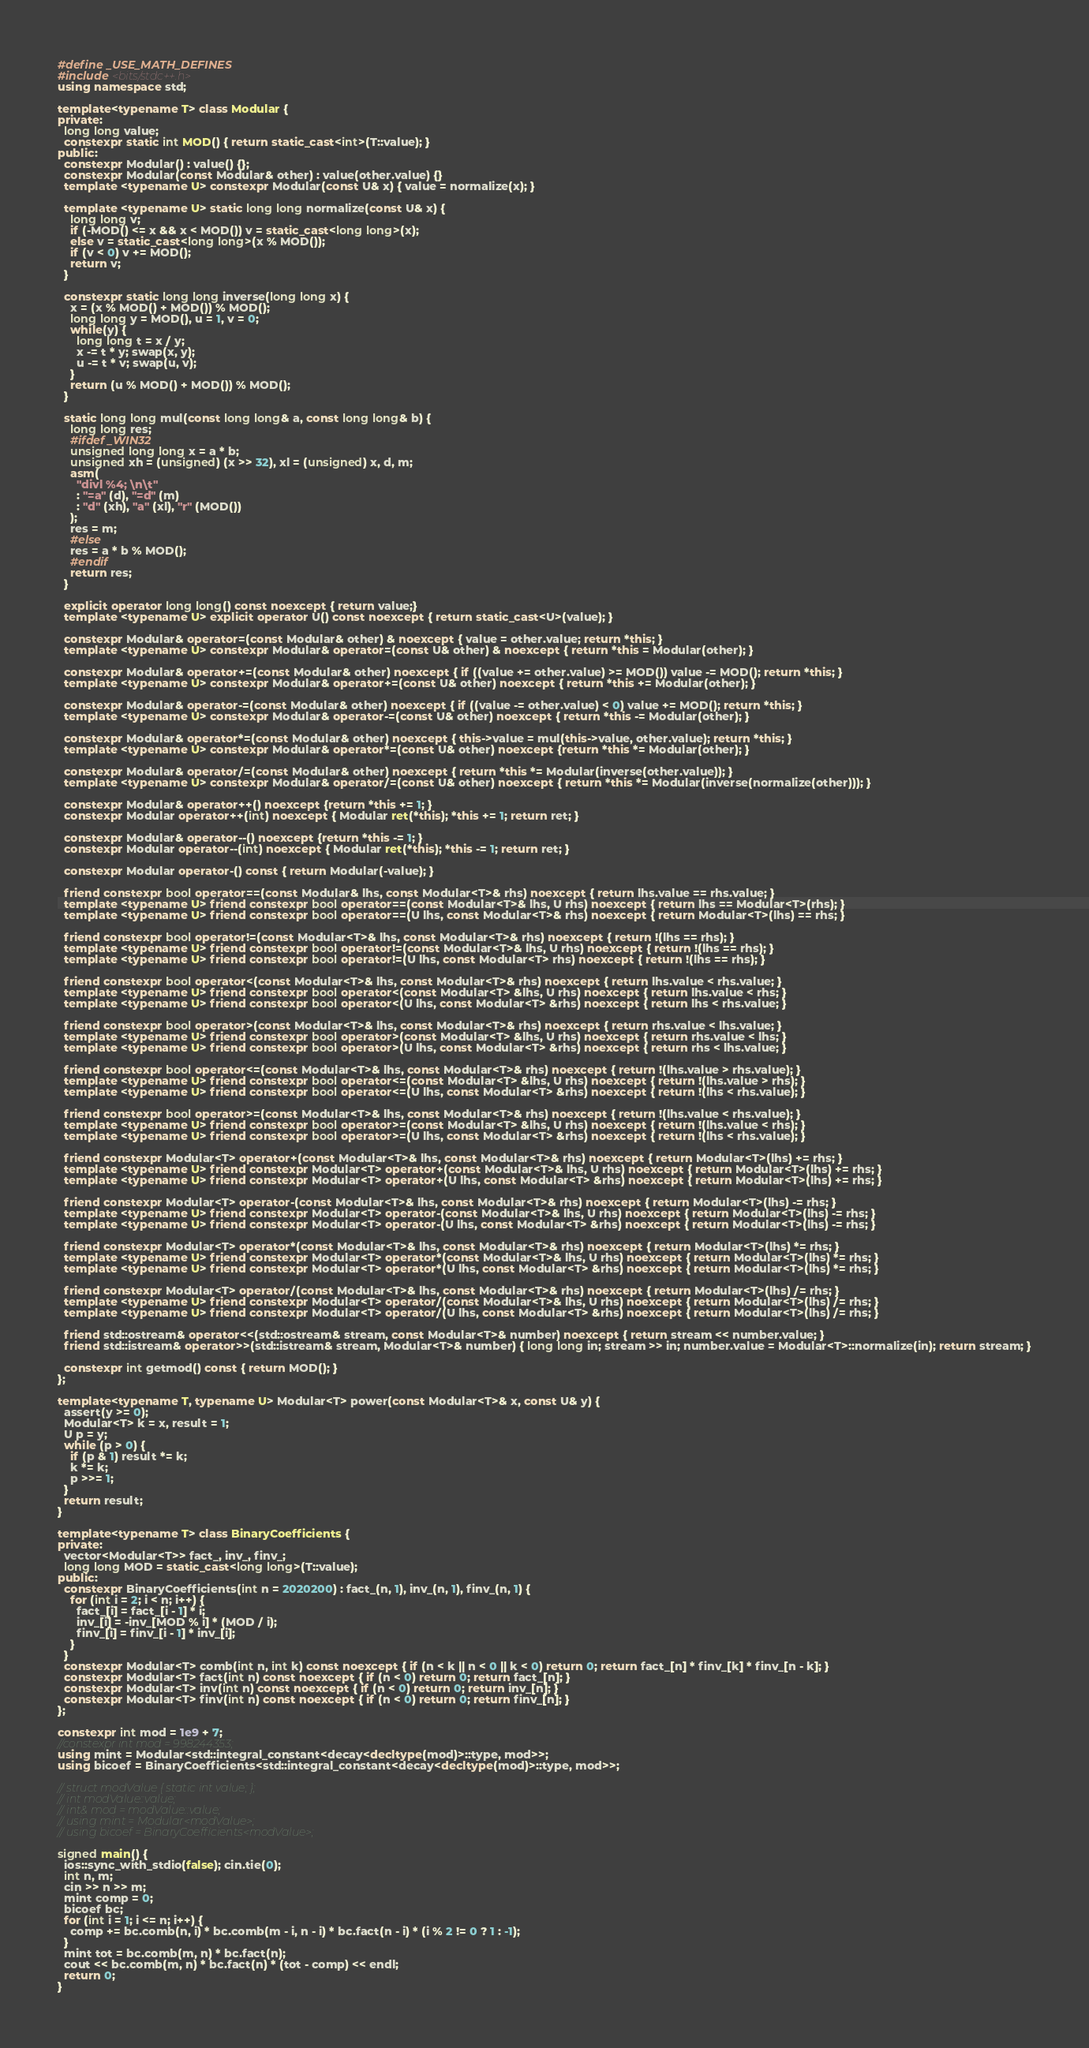<code> <loc_0><loc_0><loc_500><loc_500><_C++_>#define _USE_MATH_DEFINES
#include <bits/stdc++.h>
using namespace std;

template<typename T> class Modular {
private:
  long long value;
  constexpr static int MOD() { return static_cast<int>(T::value); }
public:
  constexpr Modular() : value() {};
  constexpr Modular(const Modular& other) : value(other.value) {}
  template <typename U> constexpr Modular(const U& x) { value = normalize(x); }

  template <typename U> static long long normalize(const U& x) {
    long long v;
    if (-MOD() <= x && x < MOD()) v = static_cast<long long>(x);
    else v = static_cast<long long>(x % MOD());
    if (v < 0) v += MOD();
    return v;
  }

  constexpr static long long inverse(long long x) {
    x = (x % MOD() + MOD()) % MOD();
    long long y = MOD(), u = 1, v = 0;
    while(y) {
      long long t = x / y;
      x -= t * y; swap(x, y);
      u -= t * v; swap(u, v);
    }
    return (u % MOD() + MOD()) % MOD();
  }
  
  static long long mul(const long long& a, const long long& b) {
    long long res;
    #ifdef _WIN32
    unsigned long long x = a * b;
    unsigned xh = (unsigned) (x >> 32), xl = (unsigned) x, d, m;
    asm(
      "divl %4; \n\t"
      : "=a" (d), "=d" (m)
      : "d" (xh), "a" (xl), "r" (MOD())
    );
    res = m;
    #else
    res = a * b % MOD();
    #endif
    return res;
  }

  explicit operator long long() const noexcept { return value;}
  template <typename U> explicit operator U() const noexcept { return static_cast<U>(value); }

  constexpr Modular& operator=(const Modular& other) & noexcept { value = other.value; return *this; }
  template <typename U> constexpr Modular& operator=(const U& other) & noexcept { return *this = Modular(other); }

  constexpr Modular& operator+=(const Modular& other) noexcept { if ((value += other.value) >= MOD()) value -= MOD(); return *this; }
  template <typename U> constexpr Modular& operator+=(const U& other) noexcept { return *this += Modular(other); }

  constexpr Modular& operator-=(const Modular& other) noexcept { if ((value -= other.value) < 0) value += MOD(); return *this; }
  template <typename U> constexpr Modular& operator-=(const U& other) noexcept { return *this -= Modular(other); }

  constexpr Modular& operator*=(const Modular& other) noexcept { this->value = mul(this->value, other.value); return *this; }
  template <typename U> constexpr Modular& operator*=(const U& other) noexcept {return *this *= Modular(other); }

  constexpr Modular& operator/=(const Modular& other) noexcept { return *this *= Modular(inverse(other.value)); }
  template <typename U> constexpr Modular& operator/=(const U& other) noexcept { return *this *= Modular(inverse(normalize(other))); }

  constexpr Modular& operator++() noexcept {return *this += 1; }
  constexpr Modular operator++(int) noexcept { Modular ret(*this); *this += 1; return ret; }

  constexpr Modular& operator--() noexcept {return *this -= 1; }
  constexpr Modular operator--(int) noexcept { Modular ret(*this); *this -= 1; return ret; }

  constexpr Modular operator-() const { return Modular(-value); }

  friend constexpr bool operator==(const Modular& lhs, const Modular<T>& rhs) noexcept { return lhs.value == rhs.value; }
  template <typename U> friend constexpr bool operator==(const Modular<T>& lhs, U rhs) noexcept { return lhs == Modular<T>(rhs); }
  template <typename U> friend constexpr bool operator==(U lhs, const Modular<T>& rhs) noexcept { return Modular<T>(lhs) == rhs; }

  friend constexpr bool operator!=(const Modular<T>& lhs, const Modular<T>& rhs) noexcept { return !(lhs == rhs); }
  template <typename U> friend constexpr bool operator!=(const Modular<T>& lhs, U rhs) noexcept { return !(lhs == rhs); }
  template <typename U> friend constexpr bool operator!=(U lhs, const Modular<T> rhs) noexcept { return !(lhs == rhs); }

  friend constexpr bool operator<(const Modular<T>& lhs, const Modular<T>& rhs) noexcept { return lhs.value < rhs.value; }
  template <typename U> friend constexpr bool operator<(const Modular<T> &lhs, U rhs) noexcept { return lhs.value < rhs; }
  template <typename U> friend constexpr bool operator<(U lhs, const Modular<T> &rhs) noexcept { return lhs < rhs.value; }

  friend constexpr bool operator>(const Modular<T>& lhs, const Modular<T>& rhs) noexcept { return rhs.value < lhs.value; }
  template <typename U> friend constexpr bool operator>(const Modular<T> &lhs, U rhs) noexcept { return rhs.value < lhs; }
  template <typename U> friend constexpr bool operator>(U lhs, const Modular<T> &rhs) noexcept { return rhs < lhs.value; }

  friend constexpr bool operator<=(const Modular<T>& lhs, const Modular<T>& rhs) noexcept { return !(lhs.value > rhs.value); }
  template <typename U> friend constexpr bool operator<=(const Modular<T> &lhs, U rhs) noexcept { return !(lhs.value > rhs); }
  template <typename U> friend constexpr bool operator<=(U lhs, const Modular<T> &rhs) noexcept { return !(lhs < rhs.value); }

  friend constexpr bool operator>=(const Modular<T>& lhs, const Modular<T>& rhs) noexcept { return !(lhs.value < rhs.value); }
  template <typename U> friend constexpr bool operator>=(const Modular<T> &lhs, U rhs) noexcept { return !(lhs.value < rhs); }
  template <typename U> friend constexpr bool operator>=(U lhs, const Modular<T> &rhs) noexcept { return !(lhs < rhs.value); }

  friend constexpr Modular<T> operator+(const Modular<T>& lhs, const Modular<T>& rhs) noexcept { return Modular<T>(lhs) += rhs; }
  template <typename U> friend constexpr Modular<T> operator+(const Modular<T>& lhs, U rhs) noexcept { return Modular<T>(lhs) += rhs; }
  template <typename U> friend constexpr Modular<T> operator+(U lhs, const Modular<T> &rhs) noexcept { return Modular<T>(lhs) += rhs; }

  friend constexpr Modular<T> operator-(const Modular<T>& lhs, const Modular<T>& rhs) noexcept { return Modular<T>(lhs) -= rhs; }
  template <typename U> friend constexpr Modular<T> operator-(const Modular<T>& lhs, U rhs) noexcept { return Modular<T>(lhs) -= rhs; }
  template <typename U> friend constexpr Modular<T> operator-(U lhs, const Modular<T> &rhs) noexcept { return Modular<T>(lhs) -= rhs; }

  friend constexpr Modular<T> operator*(const Modular<T>& lhs, const Modular<T>& rhs) noexcept { return Modular<T>(lhs) *= rhs; }
  template <typename U> friend constexpr Modular<T> operator*(const Modular<T>& lhs, U rhs) noexcept { return Modular<T>(lhs) *= rhs; }
  template <typename U> friend constexpr Modular<T> operator*(U lhs, const Modular<T> &rhs) noexcept { return Modular<T>(lhs) *= rhs; }

  friend constexpr Modular<T> operator/(const Modular<T>& lhs, const Modular<T>& rhs) noexcept { return Modular<T>(lhs) /= rhs; }
  template <typename U> friend constexpr Modular<T> operator/(const Modular<T>& lhs, U rhs) noexcept { return Modular<T>(lhs) /= rhs; }
  template <typename U> friend constexpr Modular<T> operator/(U lhs, const Modular<T> &rhs) noexcept { return Modular<T>(lhs) /= rhs; }

  friend std::ostream& operator<<(std::ostream& stream, const Modular<T>& number) noexcept { return stream << number.value; }
  friend std::istream& operator>>(std::istream& stream, Modular<T>& number) { long long in; stream >> in; number.value = Modular<T>::normalize(in); return stream; }
  
  constexpr int getmod() const { return MOD(); }
};

template<typename T, typename U> Modular<T> power(const Modular<T>& x, const U& y) {
  assert(y >= 0);
  Modular<T> k = x, result = 1;
  U p = y;
  while (p > 0) {
    if (p & 1) result *= k;
    k *= k;
    p >>= 1;
  }
  return result;
}

template<typename T> class BinaryCoefficients {
private:
  vector<Modular<T>> fact_, inv_, finv_;
  long long MOD = static_cast<long long>(T::value);
public:
  constexpr BinaryCoefficients(int n = 2020200) : fact_(n, 1), inv_(n, 1), finv_(n, 1) {
    for (int i = 2; i < n; i++) {
      fact_[i] = fact_[i - 1] * i;
      inv_[i] = -inv_[MOD % i] * (MOD / i);
      finv_[i] = finv_[i - 1] * inv_[i];
    }
  }
  constexpr Modular<T> comb(int n, int k) const noexcept { if (n < k || n < 0 || k < 0) return 0; return fact_[n] * finv_[k] * finv_[n - k]; }
  constexpr Modular<T> fact(int n) const noexcept { if (n < 0) return 0; return fact_[n]; }
  constexpr Modular<T> inv(int n) const noexcept { if (n < 0) return 0; return inv_[n]; }
  constexpr Modular<T> finv(int n) const noexcept { if (n < 0) return 0; return finv_[n]; }
};

constexpr int mod = 1e9 + 7;
//constexpr int mod = 998244353;
using mint = Modular<std::integral_constant<decay<decltype(mod)>::type, mod>>;
using bicoef = BinaryCoefficients<std::integral_constant<decay<decltype(mod)>::type, mod>>;

// struct modValue { static int value; };
// int modValue::value;
// int& mod = modValue::value;
// using mint = Modular<modValue>;
// using bicoef = BinaryCoefficients<modValue>;

signed main() { 
  ios::sync_with_stdio(false); cin.tie(0);
  int n, m;
  cin >> n >> m;
  mint comp = 0;
  bicoef bc;
  for (int i = 1; i <= n; i++) {
    comp += bc.comb(n, i) * bc.comb(m - i, n - i) * bc.fact(n - i) * (i % 2 != 0 ? 1 : -1);
  }
  mint tot = bc.comb(m, n) * bc.fact(n);
  cout << bc.comb(m, n) * bc.fact(n) * (tot - comp) << endl;
  return 0;
}</code> 